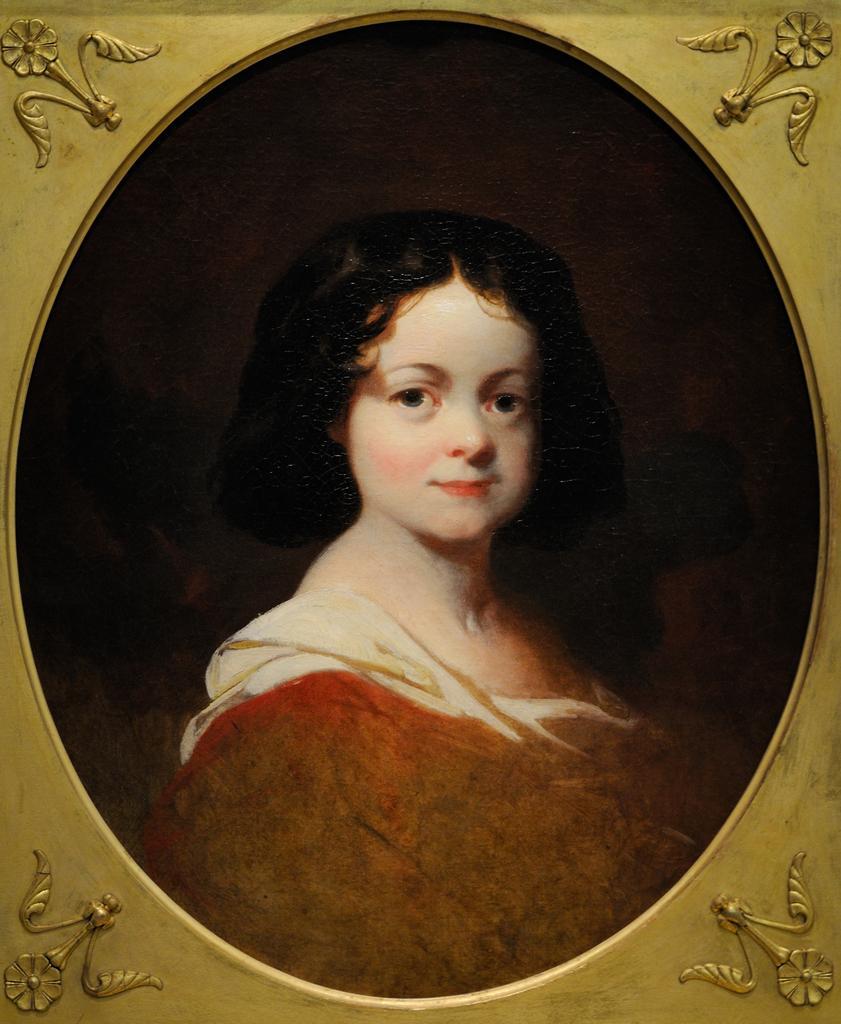Please provide a concise description of this image. In this image there is a photo frame in which there is a woman. There are flowers on the four sides of the frame. 